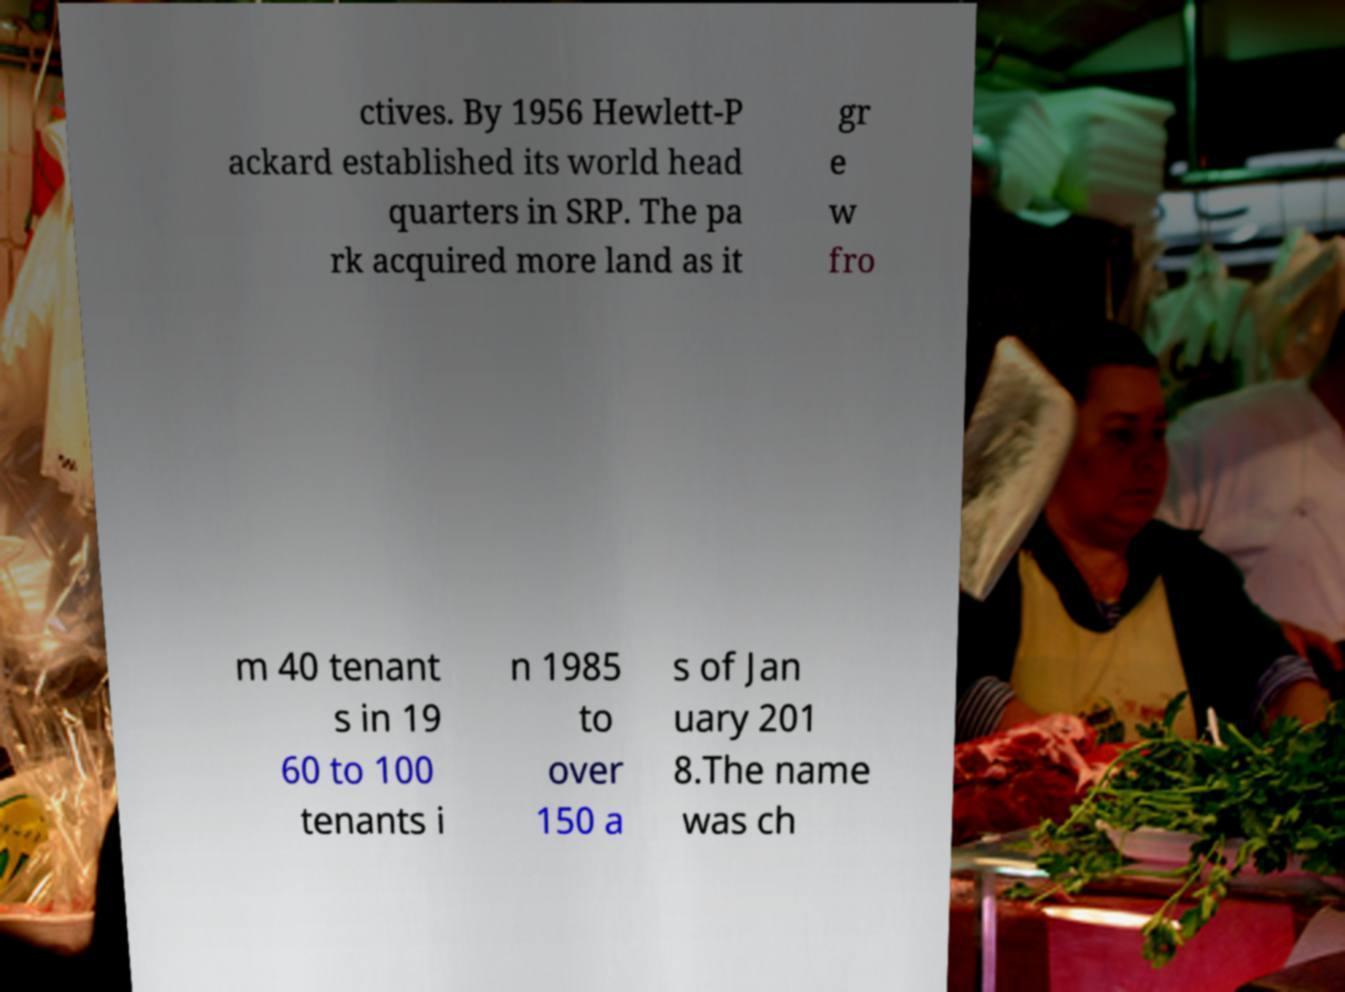What messages or text are displayed in this image? I need them in a readable, typed format. ctives. By 1956 Hewlett-P ackard established its world head quarters in SRP. The pa rk acquired more land as it gr e w fro m 40 tenant s in 19 60 to 100 tenants i n 1985 to over 150 a s of Jan uary 201 8.The name was ch 